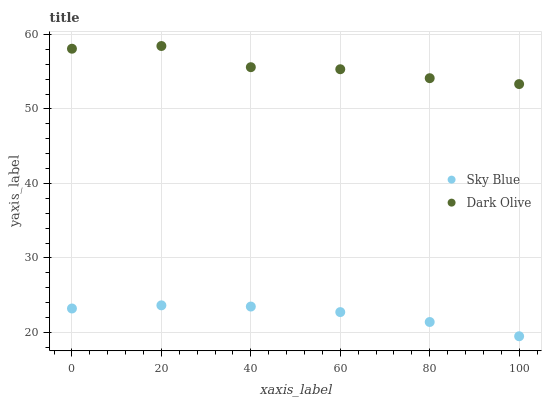Does Sky Blue have the minimum area under the curve?
Answer yes or no. Yes. Does Dark Olive have the maximum area under the curve?
Answer yes or no. Yes. Does Dark Olive have the minimum area under the curve?
Answer yes or no. No. Is Sky Blue the smoothest?
Answer yes or no. Yes. Is Dark Olive the roughest?
Answer yes or no. Yes. Is Dark Olive the smoothest?
Answer yes or no. No. Does Sky Blue have the lowest value?
Answer yes or no. Yes. Does Dark Olive have the lowest value?
Answer yes or no. No. Does Dark Olive have the highest value?
Answer yes or no. Yes. Is Sky Blue less than Dark Olive?
Answer yes or no. Yes. Is Dark Olive greater than Sky Blue?
Answer yes or no. Yes. Does Sky Blue intersect Dark Olive?
Answer yes or no. No. 